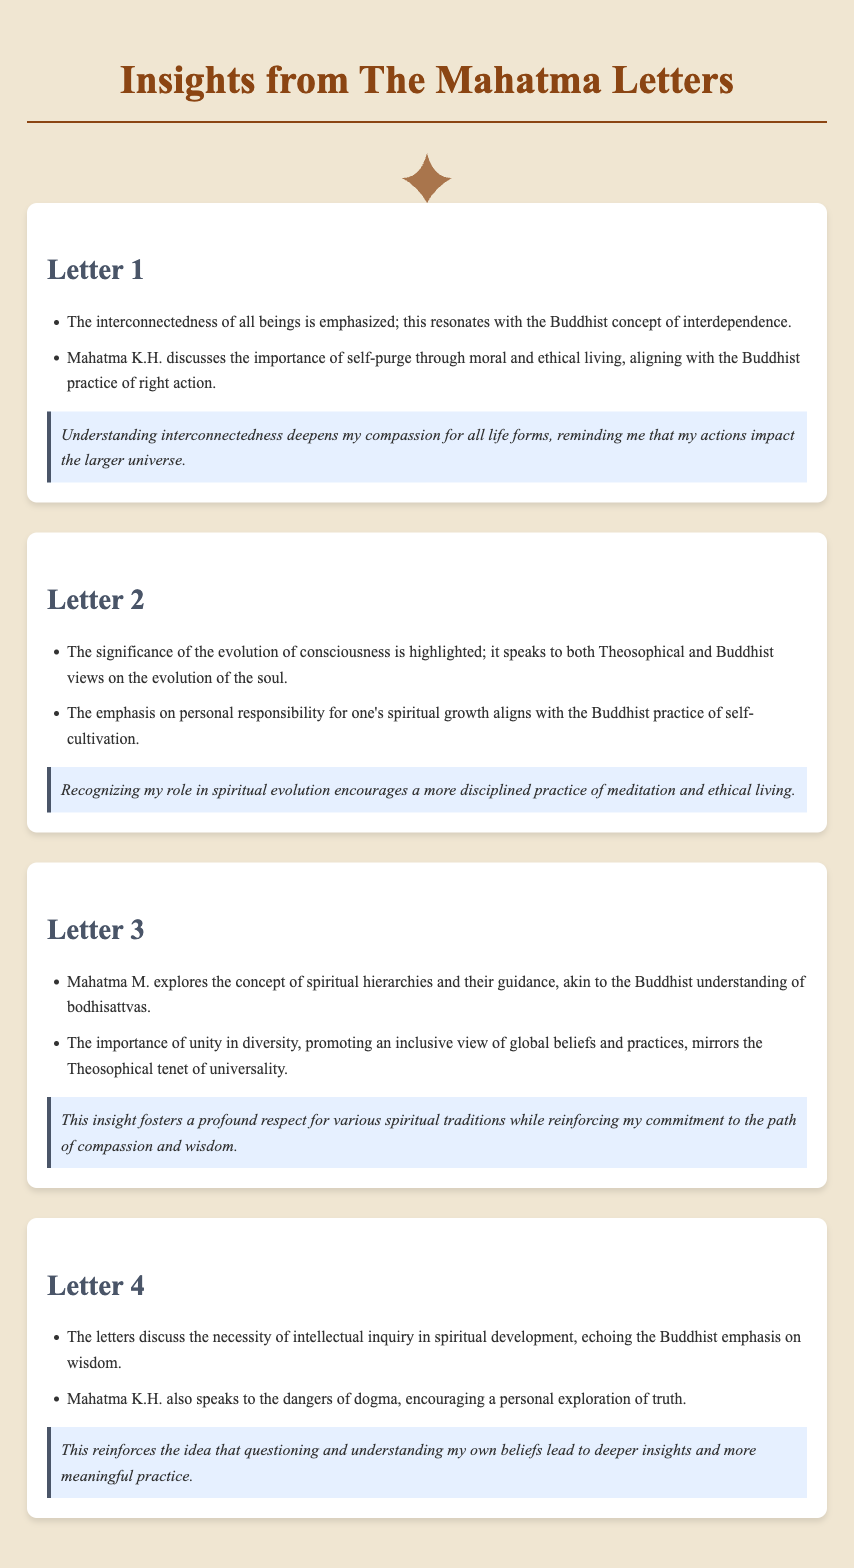What is the title of the document? The title of the document is presented at the top of the HTML content.
Answer: Insights from The Mahatma Letters How many letters are summarized in the document? The document discusses a total of four letters, as indicated by the sections.
Answer: Four Who emphasizes the interconnectedness of all beings? The author of the first letter emphasizes this concept.
Answer: Mahatma K.H What key concept is aligned with the Buddhist practice of self-cultivation? The letters highlight personal responsibility for one's spiritual growth, which resonates with this practice.
Answer: Personal responsibility What does Mahatma M. explore in the third letter? The third letter discusses spiritual hierarchies and their guidance.
Answer: Spiritual hierarchies Which Buddhist practice is discussed in connection with the necessity of intellectual inquiry? This practice relates to wisdom, which is a core tenet of Buddhist teachings.
Answer: Wisdom What is emphasized regarding the dangers mentioned by Mahatma K.H.? The letters speak to the dangers of dogma in spiritual exploration.
Answer: Dogma Which Theosophical tenet is mentioned in relation to unity in diversity? The document refers to the inclusivity of global beliefs and practices.
Answer: Universality 